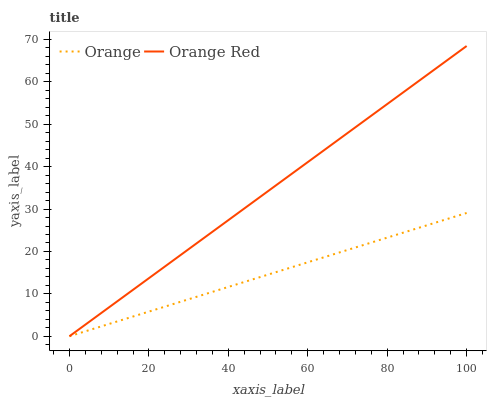Does Orange have the minimum area under the curve?
Answer yes or no. Yes. Does Orange Red have the maximum area under the curve?
Answer yes or no. Yes. Does Orange Red have the minimum area under the curve?
Answer yes or no. No. Is Orange the smoothest?
Answer yes or no. Yes. Is Orange Red the roughest?
Answer yes or no. Yes. Is Orange Red the smoothest?
Answer yes or no. No. Does Orange have the lowest value?
Answer yes or no. Yes. Does Orange Red have the highest value?
Answer yes or no. Yes. Does Orange intersect Orange Red?
Answer yes or no. Yes. Is Orange less than Orange Red?
Answer yes or no. No. Is Orange greater than Orange Red?
Answer yes or no. No. 